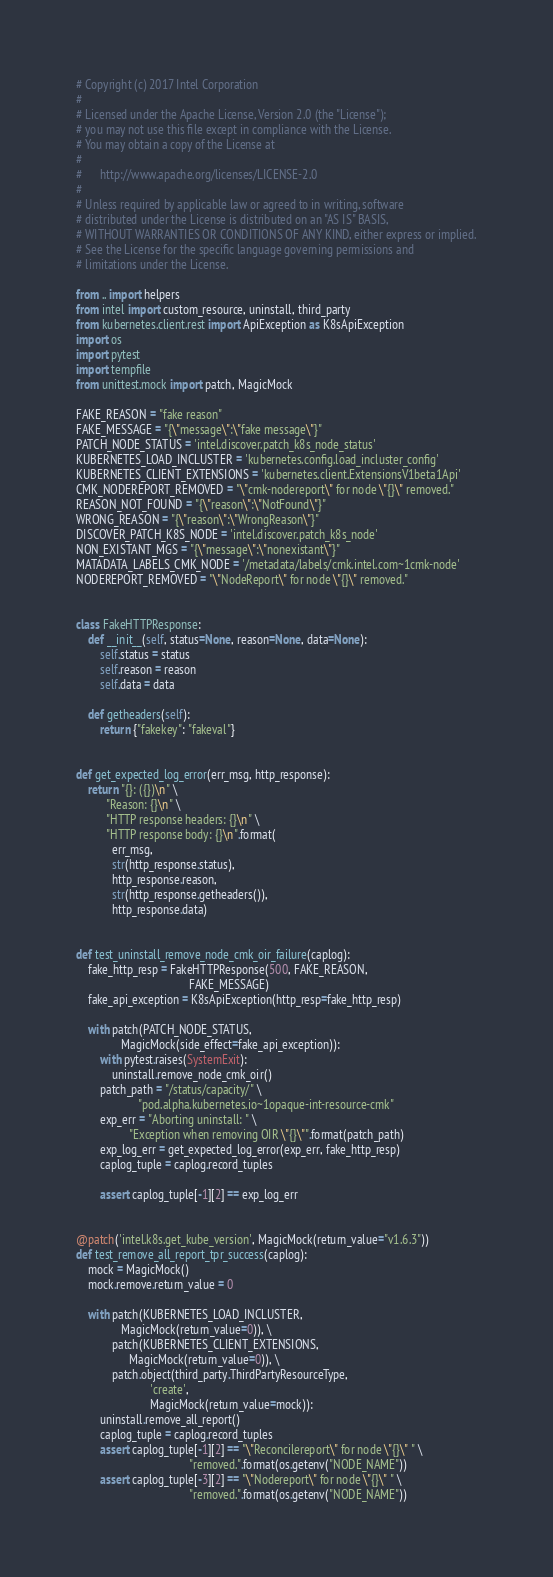Convert code to text. <code><loc_0><loc_0><loc_500><loc_500><_Python_># Copyright (c) 2017 Intel Corporation
#
# Licensed under the Apache License, Version 2.0 (the "License");
# you may not use this file except in compliance with the License.
# You may obtain a copy of the License at
#
#      http://www.apache.org/licenses/LICENSE-2.0
#
# Unless required by applicable law or agreed to in writing, software
# distributed under the License is distributed on an "AS IS" BASIS,
# WITHOUT WARRANTIES OR CONDITIONS OF ANY KIND, either express or implied.
# See the License for the specific language governing permissions and
# limitations under the License.

from .. import helpers
from intel import custom_resource, uninstall, third_party
from kubernetes.client.rest import ApiException as K8sApiException
import os
import pytest
import tempfile
from unittest.mock import patch, MagicMock

FAKE_REASON = "fake reason"
FAKE_MESSAGE = "{\"message\":\"fake message\"}"
PATCH_NODE_STATUS = 'intel.discover.patch_k8s_node_status'
KUBERNETES_LOAD_INCLUSTER = 'kubernetes.config.load_incluster_config'
KUBERNETES_CLIENT_EXTENSIONS = 'kubernetes.client.ExtensionsV1beta1Api'
CMK_NODEREPORT_REMOVED = "\"cmk-nodereport\" for node \"{}\" removed."
REASON_NOT_FOUND = "{\"reason\":\"NotFound\"}"
WRONG_REASON = "{\"reason\":\"WrongReason\"}"
DISCOVER_PATCH_K8S_NODE = 'intel.discover.patch_k8s_node'
NON_EXISTANT_MGS = "{\"message\":\"nonexistant\"}"
MATADATA_LABELS_CMK_NODE = '/metadata/labels/cmk.intel.com~1cmk-node'
NODEREPORT_REMOVED = "\"NodeReport\" for node \"{}\" removed."


class FakeHTTPResponse:
    def __init__(self, status=None, reason=None, data=None):
        self.status = status
        self.reason = reason
        self.data = data

    def getheaders(self):
        return {"fakekey": "fakeval"}


def get_expected_log_error(err_msg, http_response):
    return "{}: ({})\n" \
          "Reason: {}\n" \
          "HTTP response headers: {}\n" \
          "HTTP response body: {}\n".format(
            err_msg,
            str(http_response.status),
            http_response.reason,
            str(http_response.getheaders()),
            http_response.data)


def test_uninstall_remove_node_cmk_oir_failure(caplog):
    fake_http_resp = FakeHTTPResponse(500, FAKE_REASON,
                                      FAKE_MESSAGE)
    fake_api_exception = K8sApiException(http_resp=fake_http_resp)

    with patch(PATCH_NODE_STATUS,
               MagicMock(side_effect=fake_api_exception)):
        with pytest.raises(SystemExit):
            uninstall.remove_node_cmk_oir()
        patch_path = "/status/capacity/" \
                     "pod.alpha.kubernetes.io~1opaque-int-resource-cmk"
        exp_err = "Aborting uninstall: " \
                  "Exception when removing OIR \"{}\"".format(patch_path)
        exp_log_err = get_expected_log_error(exp_err, fake_http_resp)
        caplog_tuple = caplog.record_tuples

        assert caplog_tuple[-1][2] == exp_log_err


@patch('intel.k8s.get_kube_version', MagicMock(return_value="v1.6.3"))
def test_remove_all_report_tpr_success(caplog):
    mock = MagicMock()
    mock.remove.return_value = 0

    with patch(KUBERNETES_LOAD_INCLUSTER,
               MagicMock(return_value=0)), \
            patch(KUBERNETES_CLIENT_EXTENSIONS,
                  MagicMock(return_value=0)), \
            patch.object(third_party.ThirdPartyResourceType,
                         'create',
                         MagicMock(return_value=mock)):
        uninstall.remove_all_report()
        caplog_tuple = caplog.record_tuples
        assert caplog_tuple[-1][2] == "\"Reconcilereport\" for node \"{}\" " \
                                      "removed.".format(os.getenv("NODE_NAME"))
        assert caplog_tuple[-3][2] == "\"Nodereport\" for node \"{}\" " \
                                      "removed.".format(os.getenv("NODE_NAME"))

</code> 